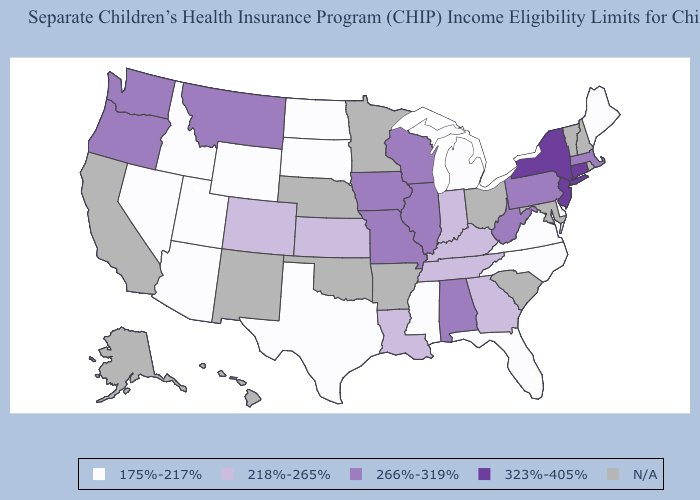What is the value of Alaska?
Concise answer only. N/A. What is the value of Virginia?
Short answer required. 175%-217%. What is the highest value in the South ?
Give a very brief answer. 266%-319%. Does Michigan have the highest value in the MidWest?
Keep it brief. No. Among the states that border Wisconsin , does Michigan have the highest value?
Give a very brief answer. No. Among the states that border Kentucky , which have the highest value?
Quick response, please. Illinois, Missouri, West Virginia. Which states hav the highest value in the West?
Answer briefly. Montana, Oregon, Washington. Name the states that have a value in the range 266%-319%?
Give a very brief answer. Alabama, Illinois, Iowa, Massachusetts, Missouri, Montana, Oregon, Pennsylvania, Washington, West Virginia, Wisconsin. Among the states that border Mississippi , does Alabama have the lowest value?
Short answer required. No. Name the states that have a value in the range 266%-319%?
Quick response, please. Alabama, Illinois, Iowa, Massachusetts, Missouri, Montana, Oregon, Pennsylvania, Washington, West Virginia, Wisconsin. Does South Dakota have the lowest value in the USA?
Be succinct. Yes. Which states have the lowest value in the MidWest?
Answer briefly. Michigan, North Dakota, South Dakota. Which states have the lowest value in the MidWest?
Quick response, please. Michigan, North Dakota, South Dakota. What is the value of Oregon?
Quick response, please. 266%-319%. 